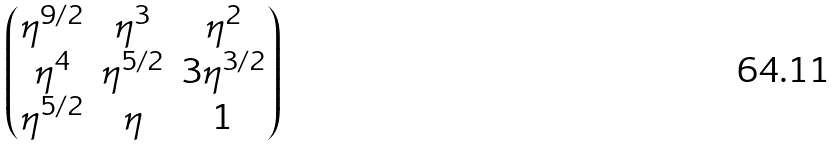Convert formula to latex. <formula><loc_0><loc_0><loc_500><loc_500>\begin{pmatrix} \eta ^ { 9 / 2 } & \eta ^ { 3 } & \eta ^ { 2 } \\ \eta ^ { 4 } & \eta ^ { 5 / 2 } & 3 \eta ^ { 3 / 2 } \\ \eta ^ { 5 / 2 } & \eta & 1 \end{pmatrix}</formula> 